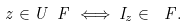Convert formula to latex. <formula><loc_0><loc_0><loc_500><loc_500>z \in U _ { \ } F \iff I _ { z } \in \ F .</formula> 